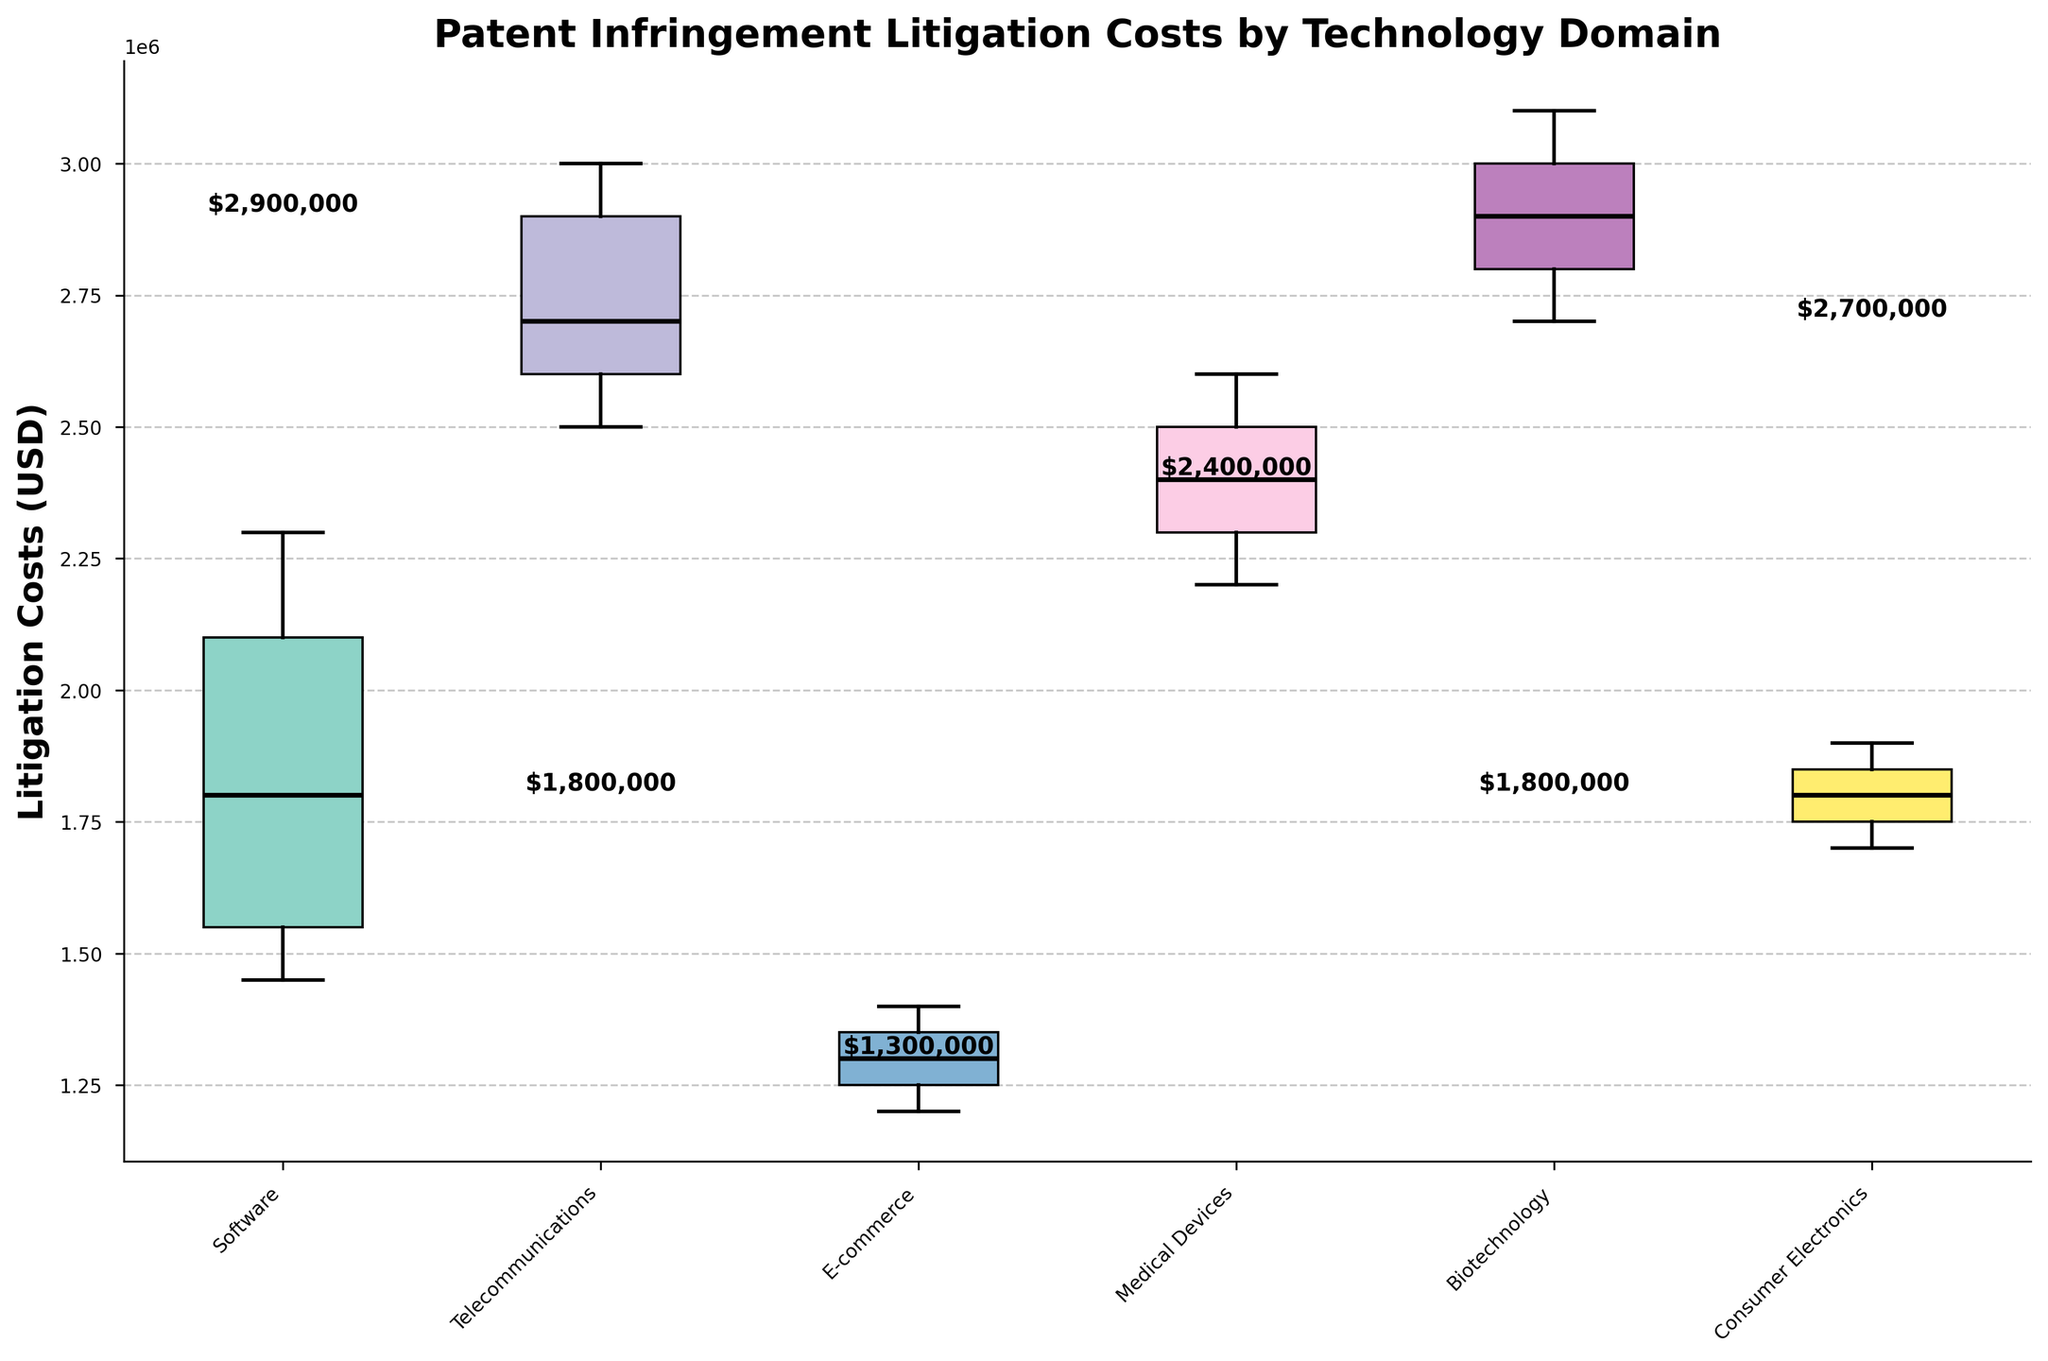What is the title of the box plot? The title of the box plot is usually placed at the top of the figure. Here, it can be identified as the text at the top.
Answer: Patent Infringement Litigation Costs by Technology Domain What is the median litigation cost for Software? To find the median litigation cost for Software, look at the horizontal line inside the Software box in the box plot. This line represents the median value.
Answer: 1,800,000 USD Which technology domain has the highest median litigation cost? To determine the technology domain with the highest median litigation cost, compare the median lines of each domain's box. The highest median line indicates the domain with the highest median cost.
Answer: Biotechnology How do the median litigation costs of Telecommunications and Medical Devices compare? Observe the median lines inside the boxes for Telecommunications and Medical Devices. The median line for Telecommunications is at 2,700,000 USD, while that for Medical Devices is at 2,300,000 USD. Comparatively, Telecommunications has a higher median litigation cost.
Answer: Telecommunications is higher What is the range of litigation costs for E-commerce? The range is determined by the difference between the upper and lower whiskers. The lower whisker seems to be at 120,000 USD and the upper at 140,000 USD for E-commerce. Calculate the difference.
Answer: 20,000 USD Between Consumer Electronics and Software, which domain has the lower upper quartile value? Analyze the top edge of the box (upper quartile) for both Consumer Electronics and Software. The upper quartile of Consumer Electronics is at 190,000 USD and for Software, it is around 210,000 USD. Thus, Consumer Electronics has a lower upper quartile value.
Answer: Consumer Electronics What is the interquartile range (IQR) for Biotechnology? The IQR is determined by the difference between the upper quartile (top edge of the box) and the lower quartile (bottom edge of the box). For Biotechnology, the upper quartile seems to be at 300,000 USD and the lower quartile at 270,000 USD. Calculate the difference.
Answer: 30,000 USD Which technology domain has the smallest spread in litigation costs? The spread is assessed by looking at the length of the box (IQR) and whiskers. A small box and short whiskers indicate a smaller spread. E-commerce, having the smallest box and whiskers, indicates the smallest spread.
Answer: E-commerce How many technology domains are presented in the plot? The technology domains can be counted by looking at the x-axis labels. Each unique label represents a different technology domain. There are six labels: Software, Telecommunications, E-commerce, Medical Devices, Biotechnology, and Consumer Electronics.
Answer: Six 